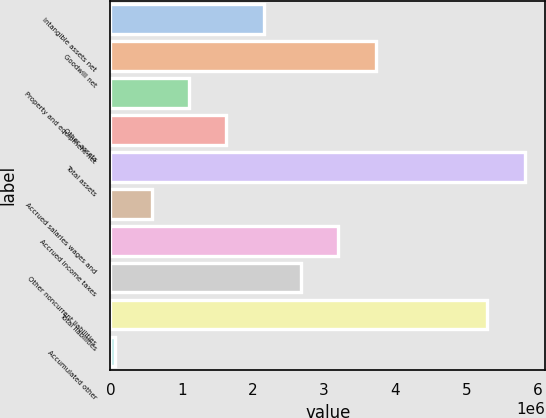Convert chart. <chart><loc_0><loc_0><loc_500><loc_500><bar_chart><fcel>Intangible assets net<fcel>Goodwill net<fcel>Property and equipment net<fcel>Other assets<fcel>Total assets<fcel>Accrued salaries wages and<fcel>Accrued income taxes<fcel>Other noncurrent liabilities<fcel>Total liabilities<fcel>Accumulated other<nl><fcel>2.15296e+06<fcel>3.72421e+06<fcel>1.10546e+06<fcel>1.62921e+06<fcel>5.81922e+06<fcel>581704<fcel>3.20046e+06<fcel>2.67671e+06<fcel>5.29547e+06<fcel>57953<nl></chart> 